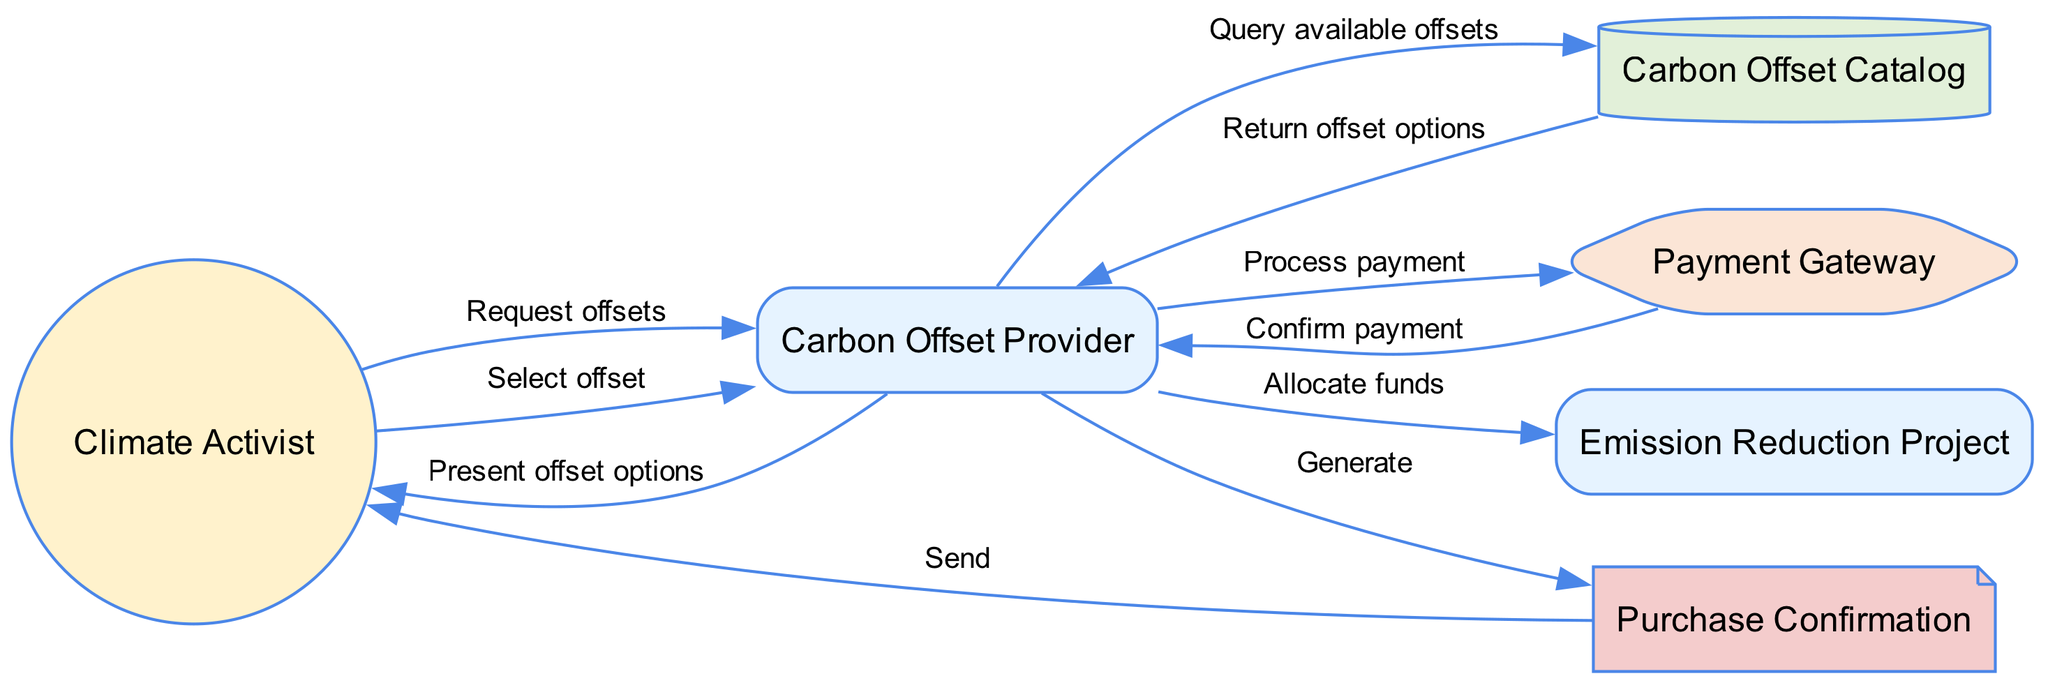What is the first action by the Climate Activist? The first action taken by the Climate Activist is to request offsets from the Carbon Offset Provider. This is the initial interaction indicated in the diagram.
Answer: Request offsets How many entities are involved in the process? There are three entities involved in the process: Carbon Offset Provider, Emission Reduction Project, and Carbon Offset Catalog. Each one plays a distinct role in the offset purchase process.
Answer: Three What does the Carbon Offset Provider do after receiving the payment confirmation? After receiving the payment confirmation from the Payment Gateway, the Carbon Offset Provider allocates funds to the Emission Reduction Project. This is the next step highlighted in the flow of the diagram.
Answer: Allocate funds Who sends the Purchase Confirmation? The Purchase Confirmation is generated by the Carbon Offset Provider and then sent to the Climate Activist. This flow indicates the final step of completing the purchase process.
Answer: Carbon Offset Provider What is the purpose of the Payment Gateway in this process? The Payment Gateway serves the purpose of processing the payment made by the Climate Activist to the Carbon Offset Provider. This indicates its role as a service in the transaction flow.
Answer: Process payment How do the Carbon Offset Provider and Climate Activist interact after presenting offset options? The Climate Activist selects an offset after the Carbon Offset Provider presents the offset options. This interaction shows the decision-making step by the activist.
Answer: Select offset Where does the Carbon Offset Catalog get queried? The Carbon Offset Catalog is queried by the Carbon Offset Provider to retrieve available offsets. This indicates its role as a source of information within the process.
Answer: Query available offsets Which notification is sent to the Climate Activist at the end? The final notification sent to the Climate Activist is the Purchase Confirmation, which indicates the completion of the purchase process.
Answer: Purchase Confirmation What shape represents the Climate Activist in the diagram? The Climate Activist is represented by a circle shape in the diagram, indicating it is an actor in the sequence.
Answer: Circle 